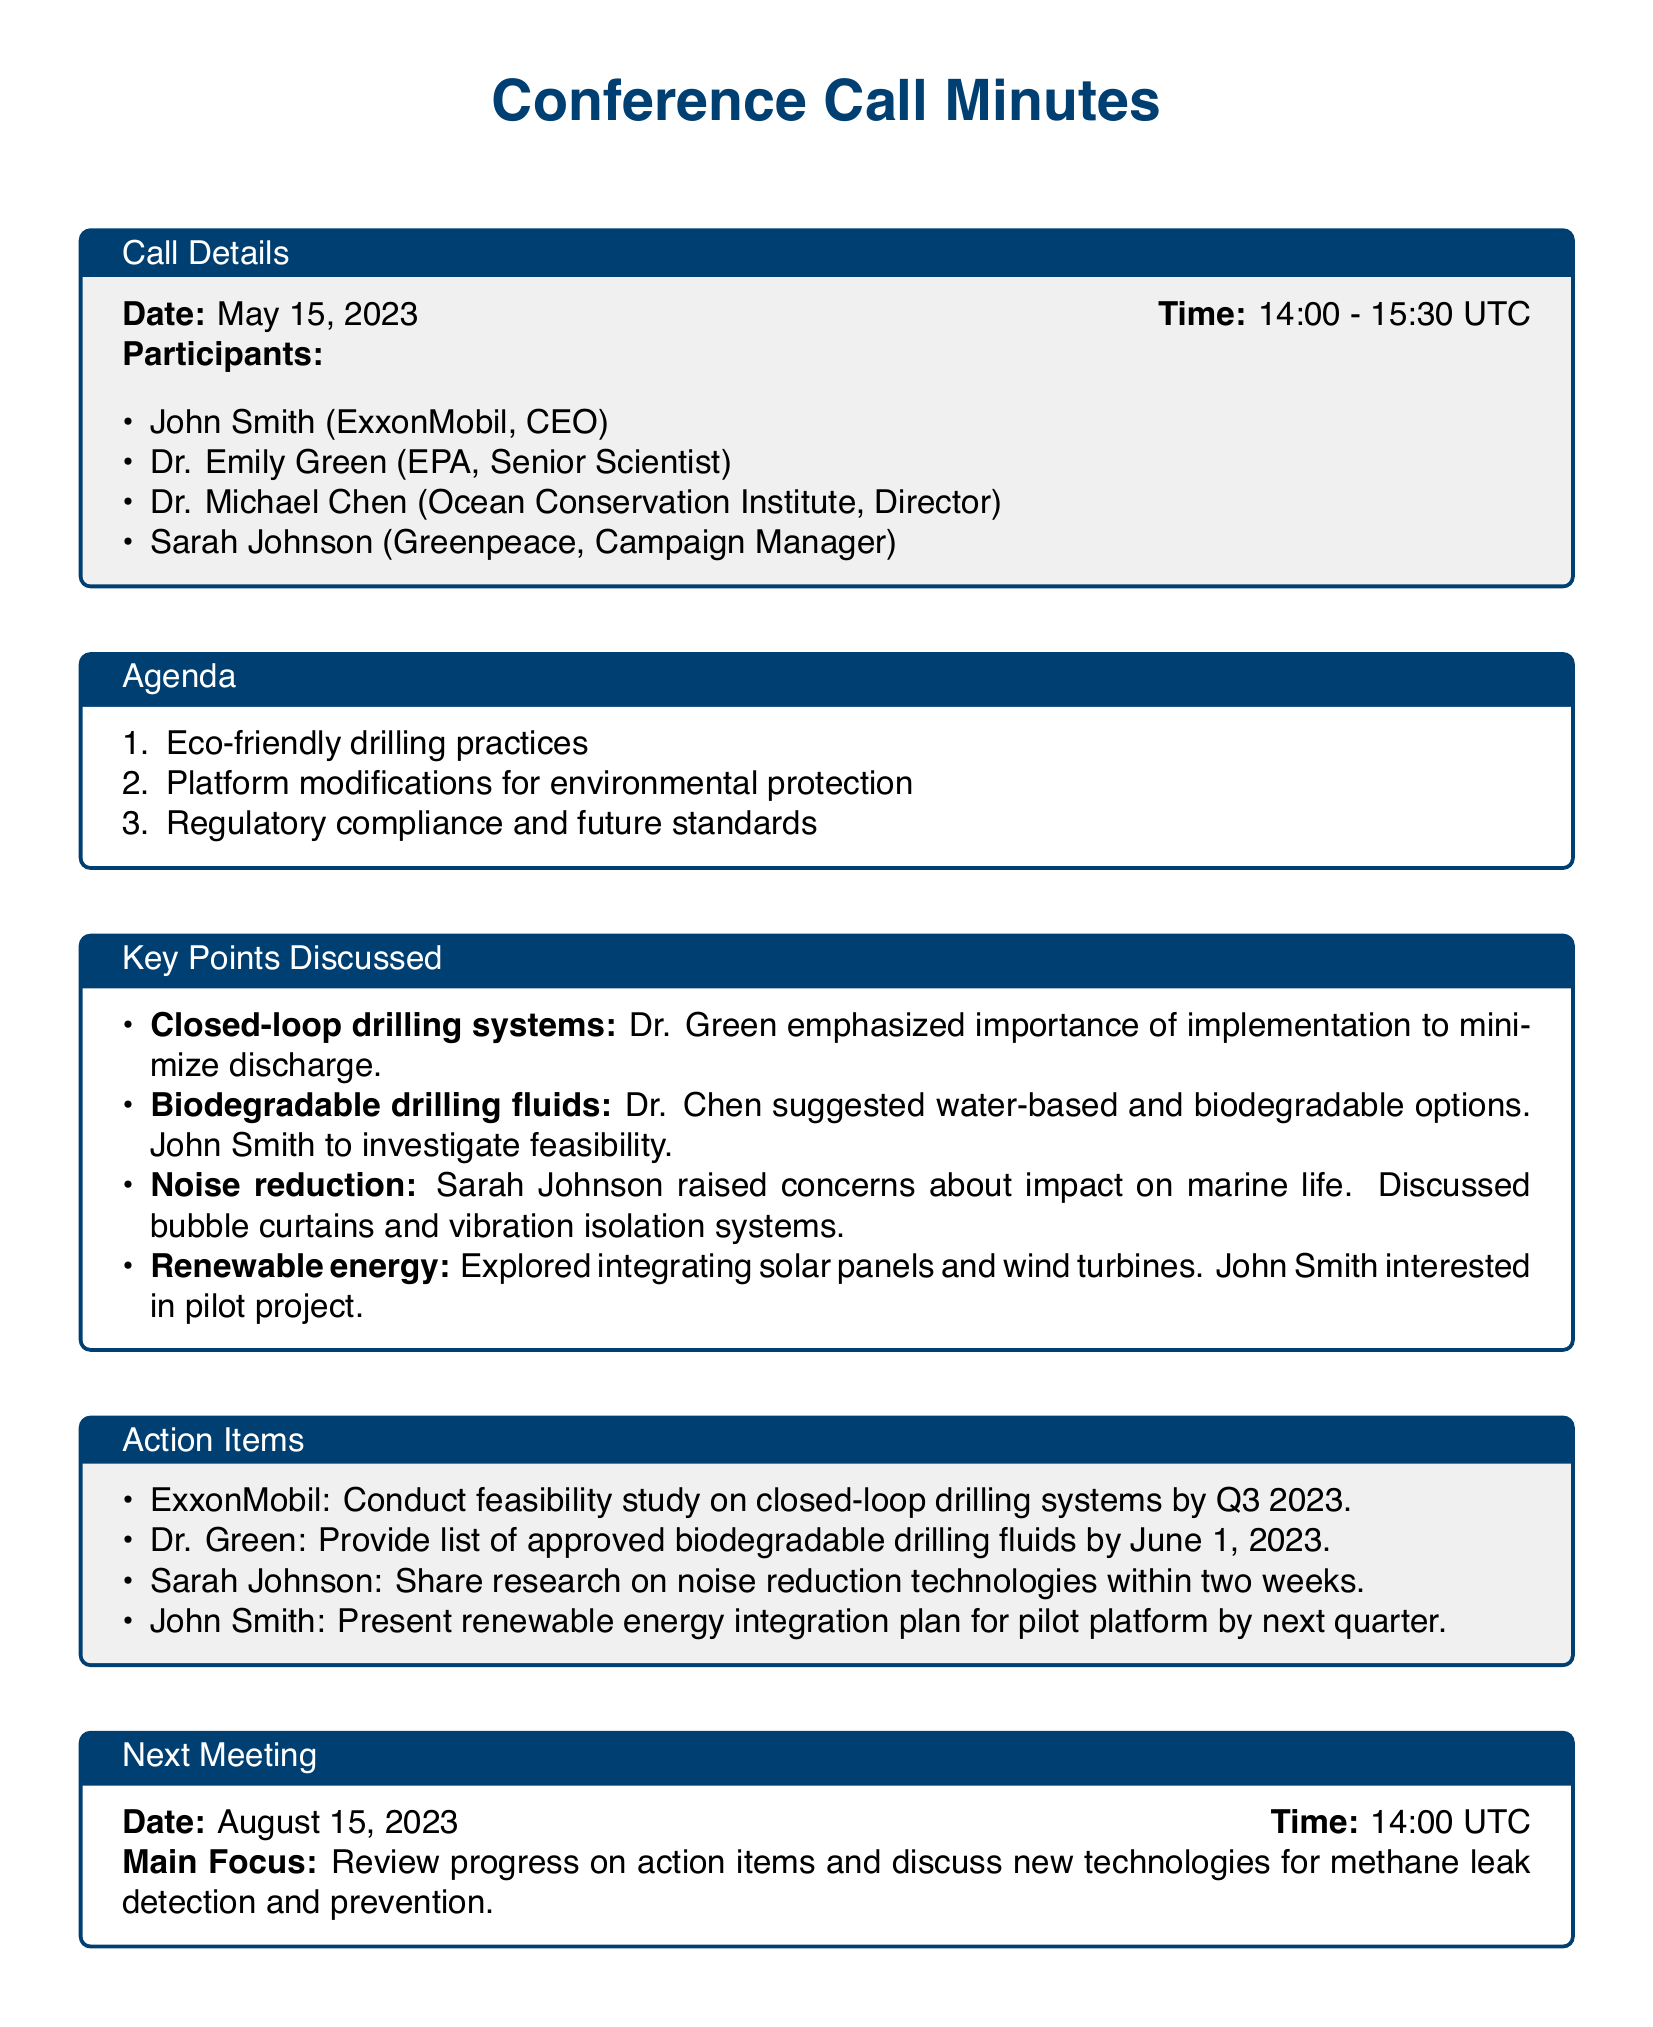what is the date of the conference call? The date of the conference call is explicitly mentioned in the document within the call details section.
Answer: May 15, 2023 who emphasized the importance of closed-loop drilling systems? The document identifies Dr. Green as the participant who emphasized the importance of closed-loop drilling systems during the call.
Answer: Dr. Green what action item is assigned to John Smith? The action item assigned to John Smith is clearly listed in the action items section of the document.
Answer: Present renewable energy integration plan for pilot platform by next quarter how long is the conference call? The duration of the conference call can be determined from the time provided in the call details section.
Answer: 1.5 hours which technology was discussed for noise reduction? The document lists the technologies discussed for noise reduction, focusing on specific measures mentioned by Sarah Johnson.
Answer: Bubble curtains and vibration isolation systems what is the main focus of the next meeting? The main focus of the next meeting is stated at the end of the document.
Answer: Review progress on action items and discuss new technologies for methane leak detection and prevention 